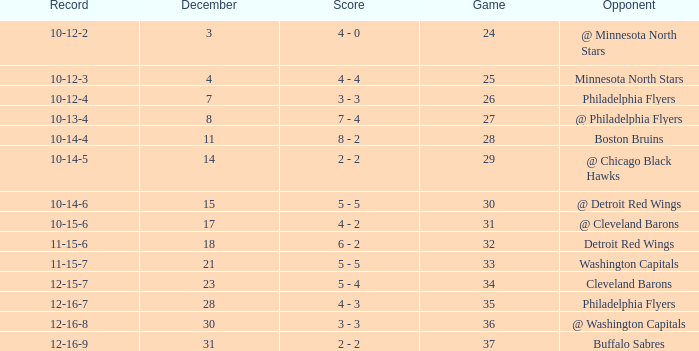What is Opponent, when Game is "37"? Buffalo Sabres. Give me the full table as a dictionary. {'header': ['Record', 'December', 'Score', 'Game', 'Opponent'], 'rows': [['10-12-2', '3', '4 - 0', '24', '@ Minnesota North Stars'], ['10-12-3', '4', '4 - 4', '25', 'Minnesota North Stars'], ['10-12-4', '7', '3 - 3', '26', 'Philadelphia Flyers'], ['10-13-4', '8', '7 - 4', '27', '@ Philadelphia Flyers'], ['10-14-4', '11', '8 - 2', '28', 'Boston Bruins'], ['10-14-5', '14', '2 - 2', '29', '@ Chicago Black Hawks'], ['10-14-6', '15', '5 - 5', '30', '@ Detroit Red Wings'], ['10-15-6', '17', '4 - 2', '31', '@ Cleveland Barons'], ['11-15-6', '18', '6 - 2', '32', 'Detroit Red Wings'], ['11-15-7', '21', '5 - 5', '33', 'Washington Capitals'], ['12-15-7', '23', '5 - 4', '34', 'Cleveland Barons'], ['12-16-7', '28', '4 - 3', '35', 'Philadelphia Flyers'], ['12-16-8', '30', '3 - 3', '36', '@ Washington Capitals'], ['12-16-9', '31', '2 - 2', '37', 'Buffalo Sabres']]} 